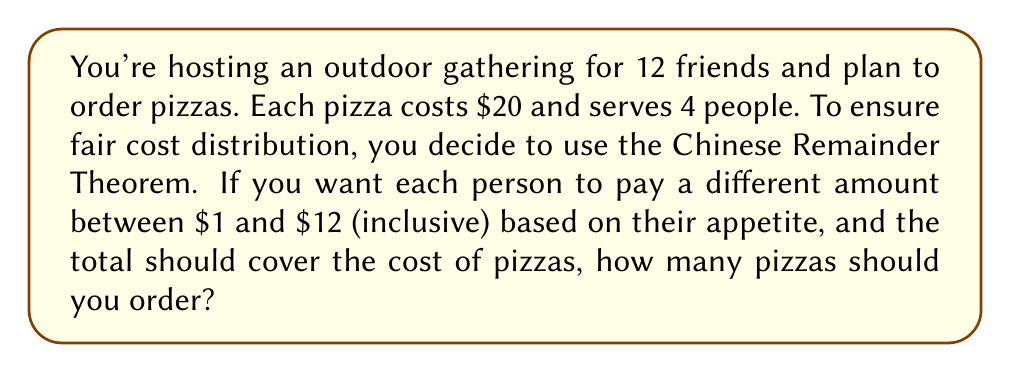Can you solve this math problem? Let's approach this step-by-step:

1) First, we need to determine the total cost that needs to be covered:
   Let $x$ be the number of pizzas.
   Total cost = $20x$

2) The sum of the amounts paid by each person should equal this total cost:
   $1 + 2 + 3 + ... + 12 = 20x$

3) We can simplify the left side using the formula for the sum of an arithmetic sequence:
   $\frac{n(a_1 + a_n)}{2} = \frac{12(1 + 12)}{2} = 78$

4) So our equation becomes:
   $78 = 20x$

5) Solving for $x$:
   $x = \frac{78}{20} = 3.9$

6) Since we can't order a fractional number of pizzas, we need to round up to 4 pizzas.

7) To verify this satisfies the Chinese Remainder Theorem conditions:
   - 4 pizzas cost $80
   - The sum of payments from 1 to 12 is $78
   - The $2 difference can be covered by the host or distributed among attendees

Therefore, ordering 4 pizzas allows for a fair distribution where each person pays a unique amount between $1 and $12, closely matching the total cost.
Answer: 4 pizzas 